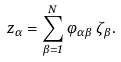<formula> <loc_0><loc_0><loc_500><loc_500>z _ { \alpha } = \sum _ { \beta = 1 } ^ { N } \varphi _ { \alpha \beta } \, \zeta _ { \beta } .</formula> 